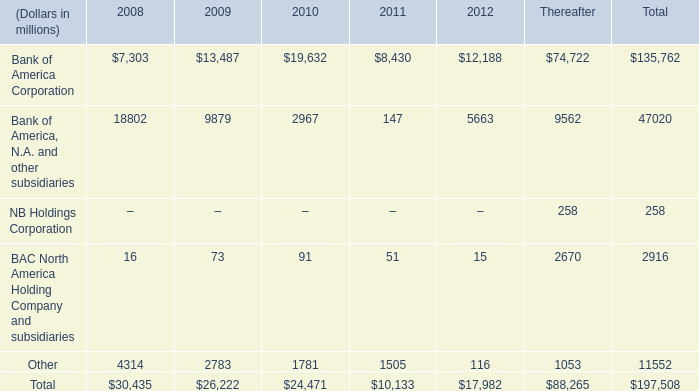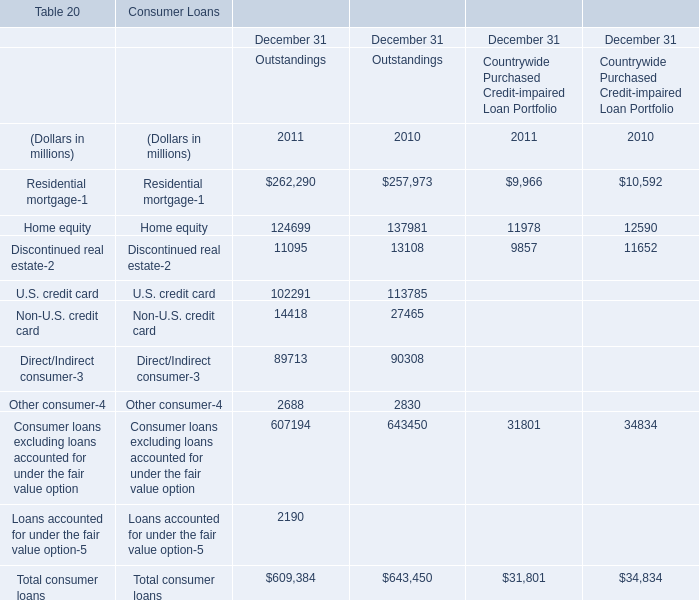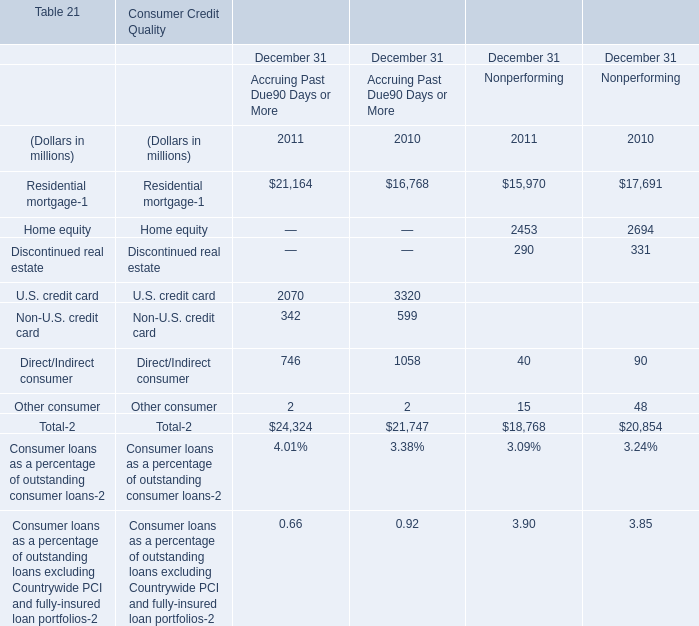In which year is Residential mortgage- positive for Outstandings? 
Answer: 2011 2010. 